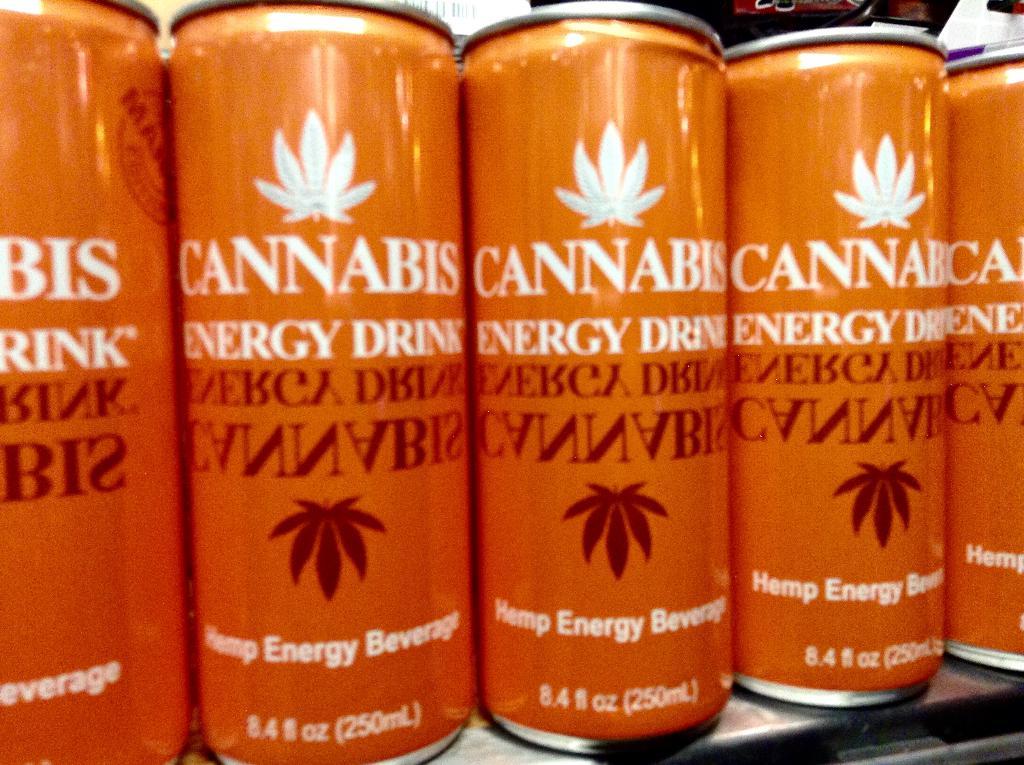What is the name of energy drink?
Give a very brief answer. Cannabis. How many ounces?
Your answer should be compact. 8.4. 